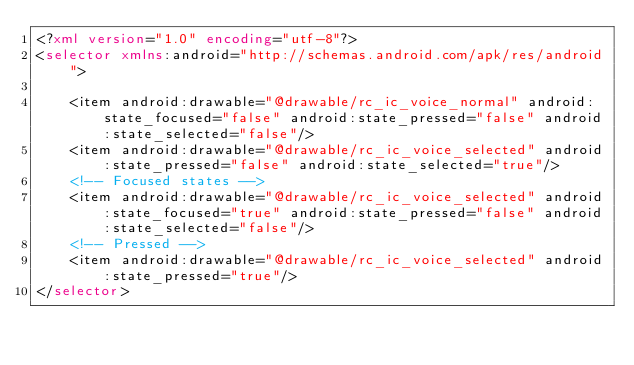<code> <loc_0><loc_0><loc_500><loc_500><_XML_><?xml version="1.0" encoding="utf-8"?>
<selector xmlns:android="http://schemas.android.com/apk/res/android">

    <item android:drawable="@drawable/rc_ic_voice_normal" android:state_focused="false" android:state_pressed="false" android:state_selected="false"/>
    <item android:drawable="@drawable/rc_ic_voice_selected" android:state_pressed="false" android:state_selected="true"/>
    <!-- Focused states -->
    <item android:drawable="@drawable/rc_ic_voice_selected" android:state_focused="true" android:state_pressed="false" android:state_selected="false"/>
    <!-- Pressed -->
    <item android:drawable="@drawable/rc_ic_voice_selected" android:state_pressed="true"/>
</selector></code> 